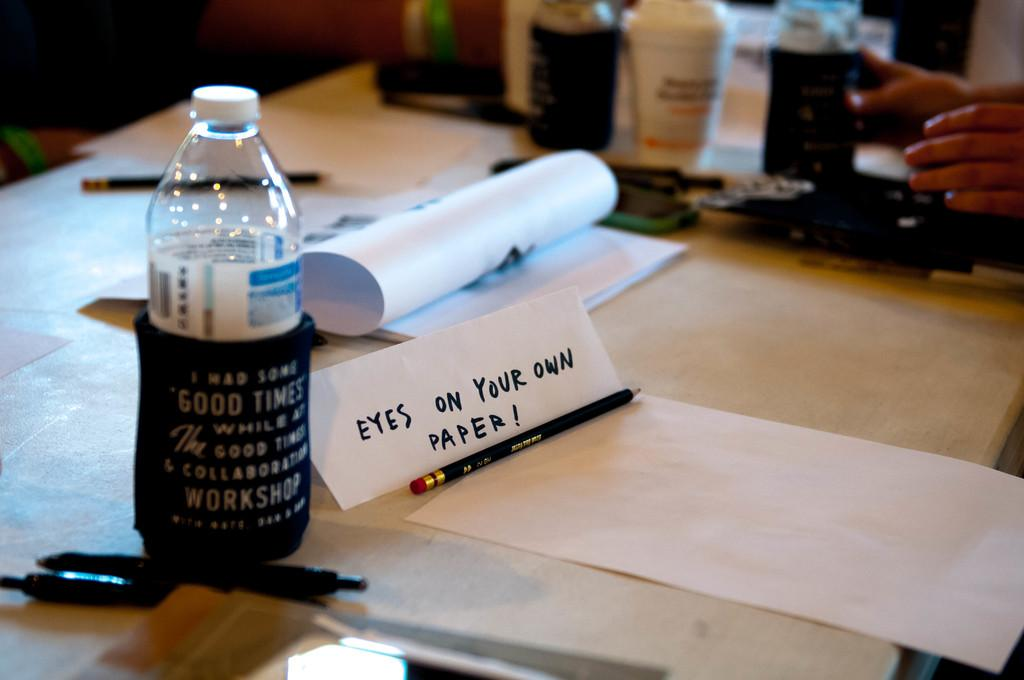<image>
Offer a succinct explanation of the picture presented. A sign standing eyes on your own paper sits next to a pencil and a bottle of water. 